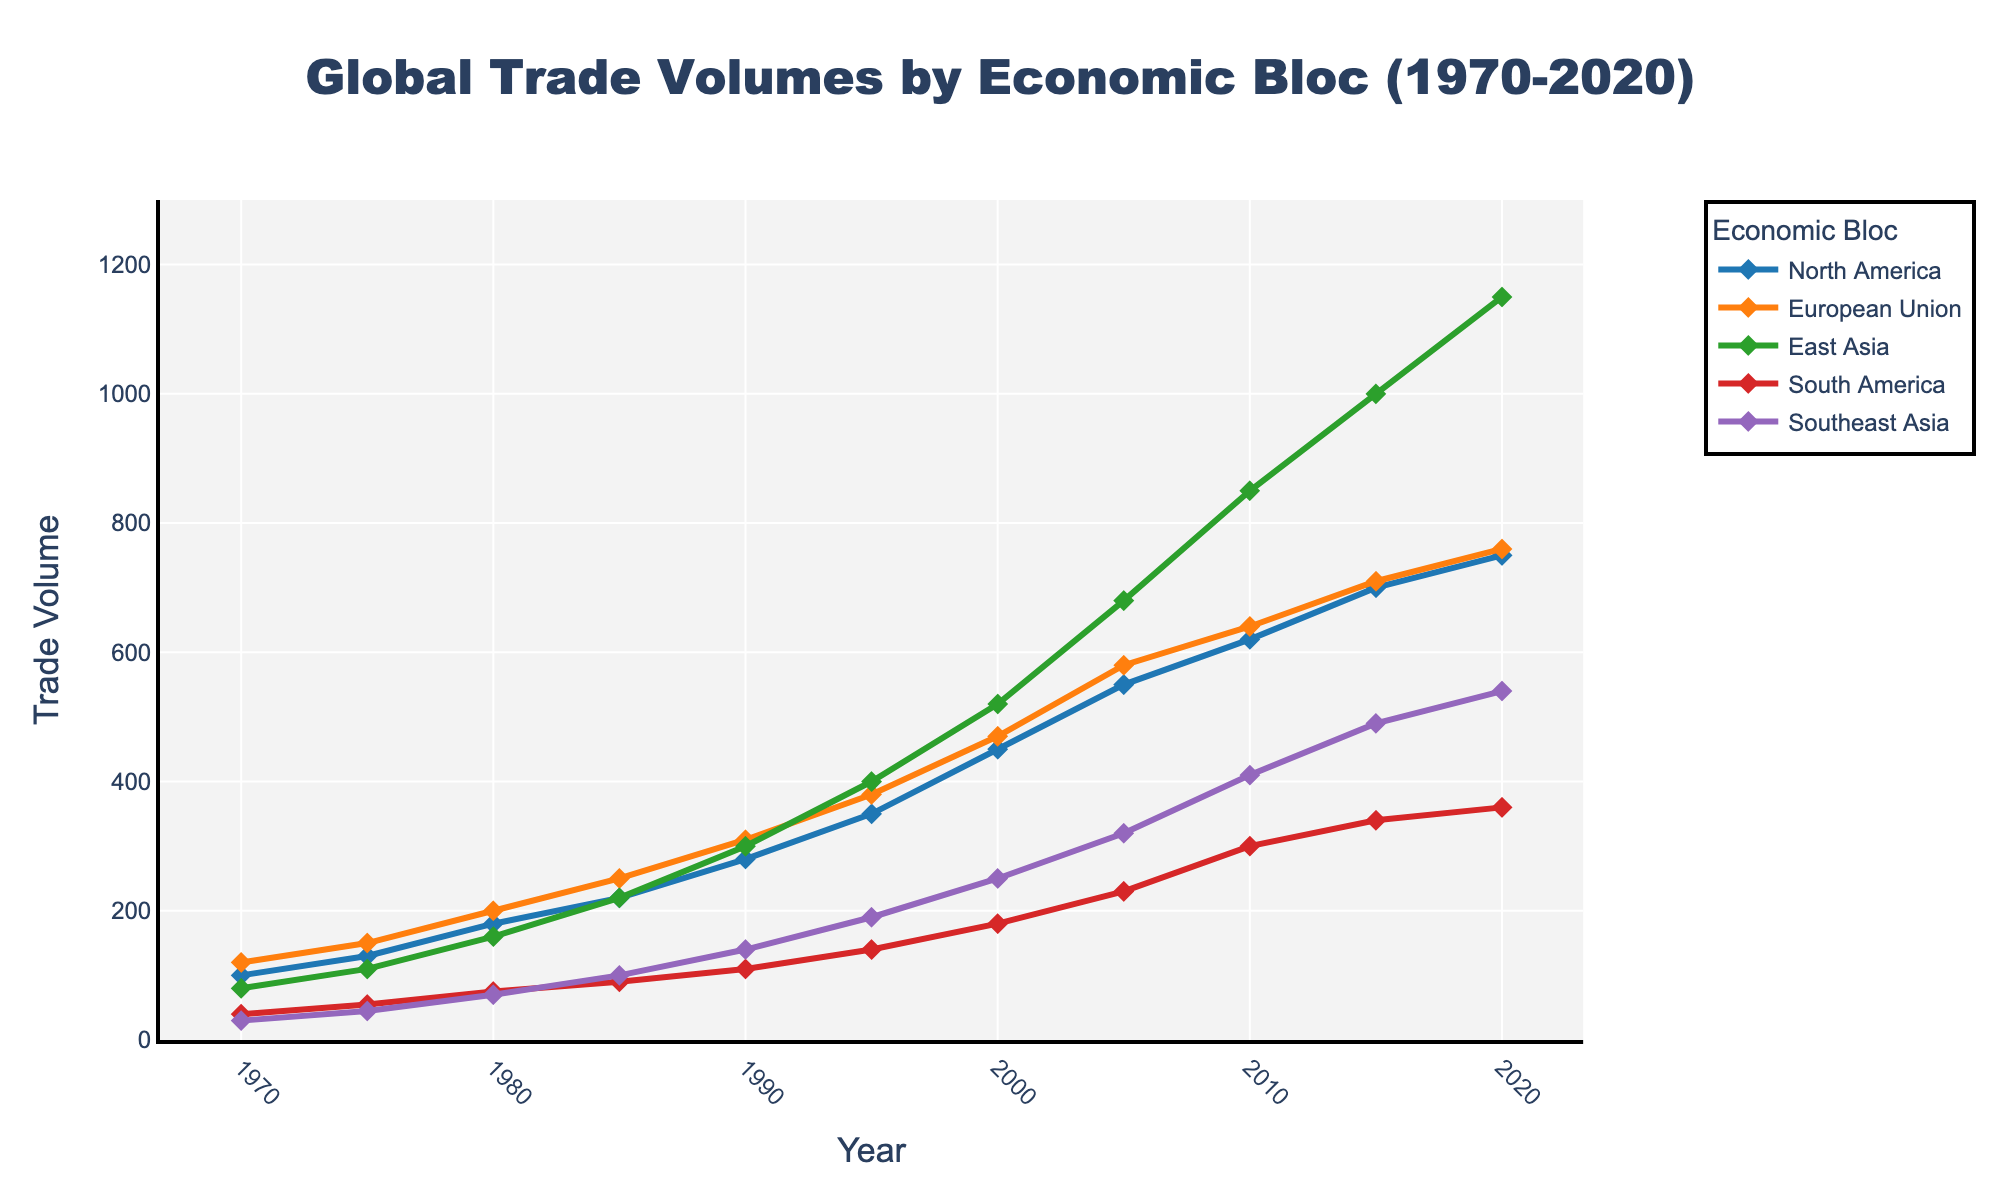Which economic bloc experienced the highest trade volume in 2020? In 2020, the trade volume of each economic bloc is represented by the height of its respective line segment. Comparing the heights visually, East Asia has the highest trade volume.
Answer: East Asia What is the difference in trade volume between European Union and North America in 1980? In the year 1980, the trade volume for North America is 180 and for the European Union is 200. Subtracting these values gives 200 - 180 = 20.
Answer: 20 Which region demonstrated the most substantial increase in trade volume from 1970 to 2020? To determine which region had the greatest increase, we need to find the difference in trade volumes from 1970 to 2020 for each region and compare them. North America increased from 100 to 750 (650), European Union from 120 to 760 (640), East Asia from 80 to 1150 (1070), South America from 40 to 360 (320), and Southeast Asia from 30 to 540 (510). East Asia had the most substantial increase.
Answer: East Asia What was the average trade volume of South America over the entire period? To find the average trade volume, sum all the trade volumes for South America and divide by the number of years. The trade volumes are 40, 55, 75, 90, 110, 140, 180, 230, 300, 340, 360. (40 + 55 + 75 + 90 + 110 + 140 + 180 + 230 + 300 + 340 + 360) / 11 = 181.8.
Answer: 181.8 In which decade did Southeast Asia see the most rapid growth in trade volume? To find the decade of most rapid growth, calculate the changes in trade volume for each decade. The growths are: 1970s: 45 - 30 = 15, 1980s: 70 - 45 = 25, 1990s: 140 - 100 = 40, 2000s: 320 - 250 = 70, 2010s: 490 - 410 = 80. The 2010s saw the most rapid growth.
Answer: 2010s How did the trade volume of the European Union in 1990 compare to that in 2000? In 1990, the trade volume for the European Union is 310, and in 2000, it is 470. The trade volume in 2000 (470) is greater than in 1990 (310).
Answer: Greater What is the combined trade volume of all regions in 1995? Summing up the trade volumes for all regions in 1995: North America (350), European Union (380), East Asia (400), South America (140), and Southeast Asia (190). The combined trade volume is 350 + 380 + 400 + 140 + 190 = 1460.
Answer: 1460 Which region had the smallest trade volume in 1970 and what was it? In 1970, comparing the trade volumes of all regions, Southeast Asia had the smallest trade volume which is 30.
Answer: Southeast Asia, 30 